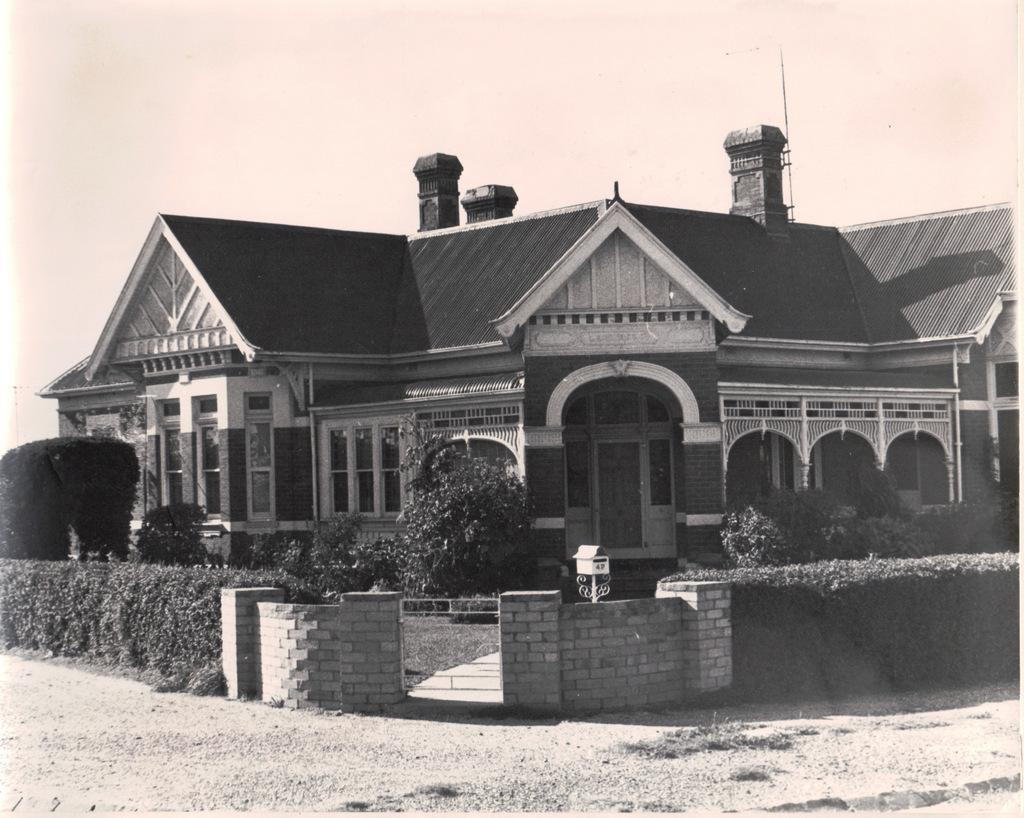What is located in the foreground of the image? There is a house, plants, a wall, a gate, and the sky visible in the foreground of the image. Can you describe the plants in the foreground of the image? The plants in the foreground of the image are not specified, but they are present alongside the other elements. What architectural feature can be seen in the foreground of the image? There is a gate in the foreground of the image. What is visible above the elements in the foreground of the image? The sky is visible in the foreground of the image. What is present at the bottom of the image? The ground is present at the bottom of the image. What type of jelly is being used to hold the gate in the image? There is no jelly present in the image; the gate is likely held in place by hinges or another type of hardware. How many wings can be seen on the house in the image? The image does not show any wings on the house; it is a typical house with a roof and walls. 